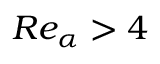Convert formula to latex. <formula><loc_0><loc_0><loc_500><loc_500>R e _ { \alpha } > 4</formula> 